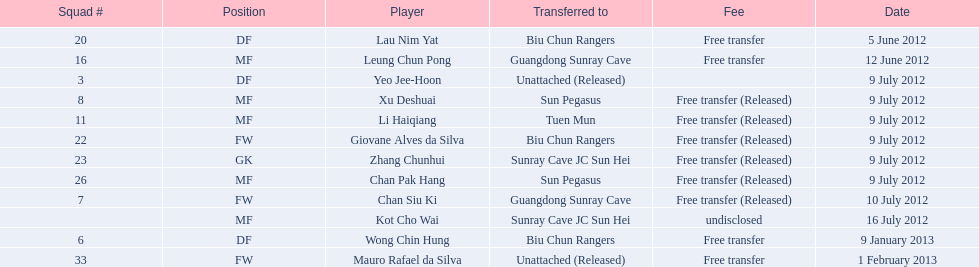Which players have been named? Lau Nim Yat, Leung Chun Pong, Yeo Jee-Hoon, Xu Deshuai, Li Haiqiang, Giovane Alves da Silva, Zhang Chunhui, Chan Pak Hang, Chan Siu Ki, Kot Cho Wai, Wong Chin Hung, Mauro Rafael da Silva. When did they move to biu chun rangers? 5 June 2012, 9 July 2012, 9 January 2013. From those, what is the transfer date of wong chin hung? 9 January 2013. 